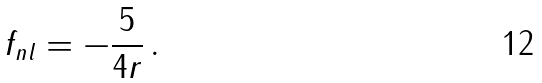<formula> <loc_0><loc_0><loc_500><loc_500>f _ { n l } = - \frac { 5 } { 4 r } \, .</formula> 